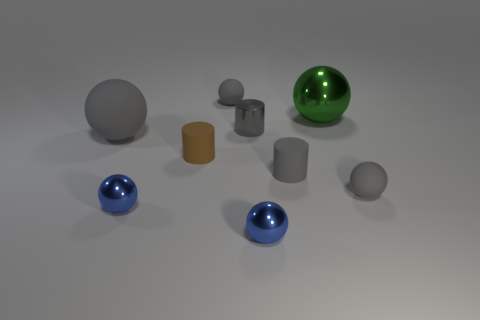Subtract all gray metallic cylinders. How many cylinders are left? 2 Subtract all gray balls. How many balls are left? 3 Subtract 4 spheres. How many spheres are left? 2 Subtract all balls. How many objects are left? 3 Subtract all yellow balls. How many gray cylinders are left? 2 Subtract all brown spheres. Subtract all blue cylinders. How many spheres are left? 6 Subtract all tiny yellow metallic cubes. Subtract all brown rubber cylinders. How many objects are left? 8 Add 1 big green spheres. How many big green spheres are left? 2 Add 3 large purple shiny objects. How many large purple shiny objects exist? 3 Subtract 0 purple spheres. How many objects are left? 9 